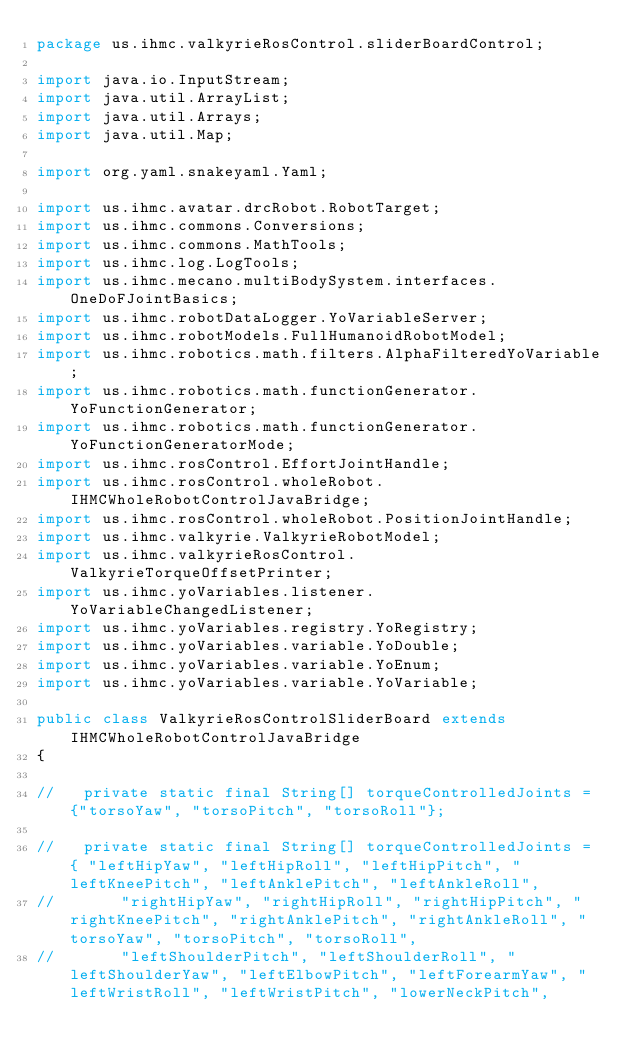<code> <loc_0><loc_0><loc_500><loc_500><_Java_>package us.ihmc.valkyrieRosControl.sliderBoardControl;

import java.io.InputStream;
import java.util.ArrayList;
import java.util.Arrays;
import java.util.Map;

import org.yaml.snakeyaml.Yaml;

import us.ihmc.avatar.drcRobot.RobotTarget;
import us.ihmc.commons.Conversions;
import us.ihmc.commons.MathTools;
import us.ihmc.log.LogTools;
import us.ihmc.mecano.multiBodySystem.interfaces.OneDoFJointBasics;
import us.ihmc.robotDataLogger.YoVariableServer;
import us.ihmc.robotModels.FullHumanoidRobotModel;
import us.ihmc.robotics.math.filters.AlphaFilteredYoVariable;
import us.ihmc.robotics.math.functionGenerator.YoFunctionGenerator;
import us.ihmc.robotics.math.functionGenerator.YoFunctionGeneratorMode;
import us.ihmc.rosControl.EffortJointHandle;
import us.ihmc.rosControl.wholeRobot.IHMCWholeRobotControlJavaBridge;
import us.ihmc.rosControl.wholeRobot.PositionJointHandle;
import us.ihmc.valkyrie.ValkyrieRobotModel;
import us.ihmc.valkyrieRosControl.ValkyrieTorqueOffsetPrinter;
import us.ihmc.yoVariables.listener.YoVariableChangedListener;
import us.ihmc.yoVariables.registry.YoRegistry;
import us.ihmc.yoVariables.variable.YoDouble;
import us.ihmc.yoVariables.variable.YoEnum;
import us.ihmc.yoVariables.variable.YoVariable;

public class ValkyrieRosControlSliderBoard extends IHMCWholeRobotControlJavaBridge
{

//   private static final String[] torqueControlledJoints = {"torsoYaw", "torsoPitch", "torsoRoll"};

//   private static final String[] torqueControlledJoints = { "leftHipYaw", "leftHipRoll", "leftHipPitch", "leftKneePitch", "leftAnklePitch", "leftAnkleRoll",
//       "rightHipYaw", "rightHipRoll", "rightHipPitch", "rightKneePitch", "rightAnklePitch", "rightAnkleRoll", "torsoYaw", "torsoPitch", "torsoRoll",
//       "leftShoulderPitch", "leftShoulderRoll", "leftShoulderYaw", "leftElbowPitch", "leftForearmYaw", "leftWristRoll", "leftWristPitch", "lowerNeckPitch",</code> 